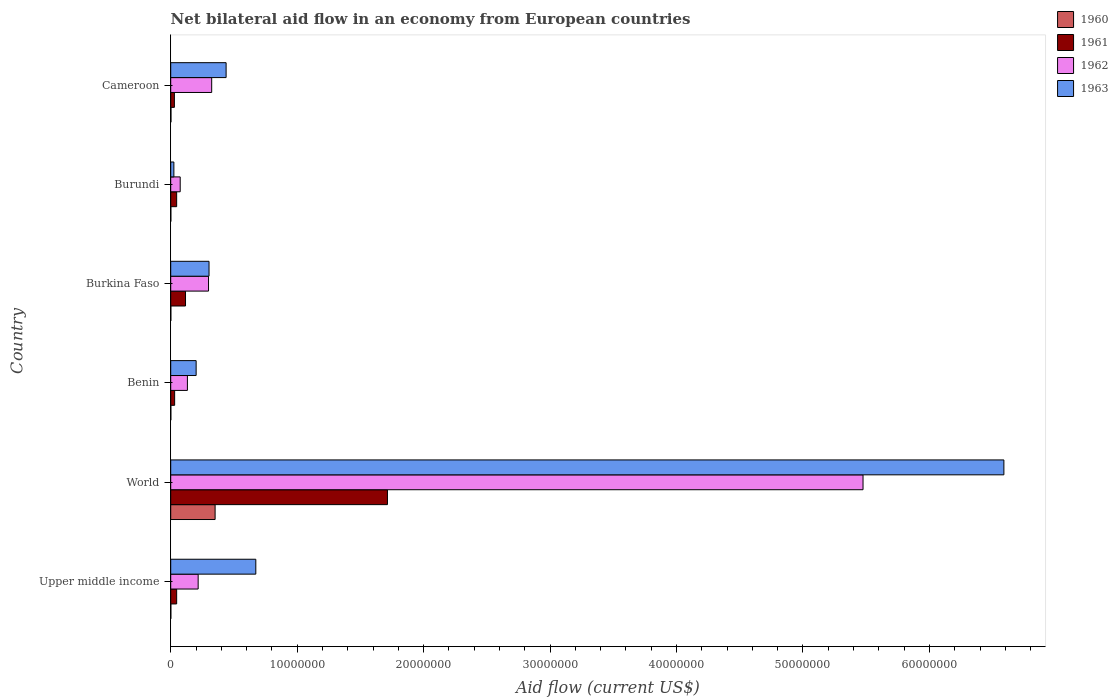How many different coloured bars are there?
Your answer should be very brief. 4. How many groups of bars are there?
Your answer should be very brief. 6. How many bars are there on the 5th tick from the top?
Provide a short and direct response. 4. How many bars are there on the 3rd tick from the bottom?
Give a very brief answer. 4. What is the label of the 2nd group of bars from the top?
Make the answer very short. Burundi. In how many cases, is the number of bars for a given country not equal to the number of legend labels?
Your answer should be compact. 0. Across all countries, what is the maximum net bilateral aid flow in 1960?
Provide a succinct answer. 3.51e+06. Across all countries, what is the minimum net bilateral aid flow in 1960?
Make the answer very short. 10000. In which country was the net bilateral aid flow in 1963 maximum?
Provide a short and direct response. World. In which country was the net bilateral aid flow in 1960 minimum?
Give a very brief answer. Upper middle income. What is the total net bilateral aid flow in 1962 in the graph?
Offer a very short reply. 6.52e+07. What is the difference between the net bilateral aid flow in 1960 in Burundi and that in Cameroon?
Offer a very short reply. -10000. What is the difference between the net bilateral aid flow in 1962 in Burkina Faso and the net bilateral aid flow in 1960 in Benin?
Give a very brief answer. 2.98e+06. What is the average net bilateral aid flow in 1963 per country?
Keep it short and to the point. 1.37e+07. What is the difference between the net bilateral aid flow in 1961 and net bilateral aid flow in 1963 in Cameroon?
Your answer should be compact. -4.09e+06. In how many countries, is the net bilateral aid flow in 1962 greater than 16000000 US$?
Provide a short and direct response. 1. What is the ratio of the net bilateral aid flow in 1961 in Benin to that in Burundi?
Provide a short and direct response. 0.66. Is the difference between the net bilateral aid flow in 1961 in Cameroon and World greater than the difference between the net bilateral aid flow in 1963 in Cameroon and World?
Offer a terse response. Yes. What is the difference between the highest and the second highest net bilateral aid flow in 1963?
Ensure brevity in your answer.  5.92e+07. What is the difference between the highest and the lowest net bilateral aid flow in 1960?
Your answer should be compact. 3.50e+06. Is it the case that in every country, the sum of the net bilateral aid flow in 1962 and net bilateral aid flow in 1963 is greater than the sum of net bilateral aid flow in 1961 and net bilateral aid flow in 1960?
Your response must be concise. No. Is it the case that in every country, the sum of the net bilateral aid flow in 1961 and net bilateral aid flow in 1963 is greater than the net bilateral aid flow in 1962?
Ensure brevity in your answer.  No. How many bars are there?
Offer a very short reply. 24. Are all the bars in the graph horizontal?
Provide a short and direct response. Yes. How many countries are there in the graph?
Your answer should be compact. 6. Does the graph contain grids?
Your answer should be compact. No. Where does the legend appear in the graph?
Make the answer very short. Top right. How many legend labels are there?
Your response must be concise. 4. How are the legend labels stacked?
Keep it short and to the point. Vertical. What is the title of the graph?
Make the answer very short. Net bilateral aid flow in an economy from European countries. Does "1999" appear as one of the legend labels in the graph?
Make the answer very short. No. What is the label or title of the X-axis?
Keep it short and to the point. Aid flow (current US$). What is the label or title of the Y-axis?
Offer a very short reply. Country. What is the Aid flow (current US$) in 1961 in Upper middle income?
Provide a short and direct response. 4.70e+05. What is the Aid flow (current US$) of 1962 in Upper middle income?
Give a very brief answer. 2.17e+06. What is the Aid flow (current US$) in 1963 in Upper middle income?
Your response must be concise. 6.73e+06. What is the Aid flow (current US$) of 1960 in World?
Make the answer very short. 3.51e+06. What is the Aid flow (current US$) of 1961 in World?
Provide a short and direct response. 1.71e+07. What is the Aid flow (current US$) of 1962 in World?
Provide a succinct answer. 5.48e+07. What is the Aid flow (current US$) of 1963 in World?
Give a very brief answer. 6.59e+07. What is the Aid flow (current US$) of 1960 in Benin?
Make the answer very short. 10000. What is the Aid flow (current US$) of 1961 in Benin?
Offer a very short reply. 3.10e+05. What is the Aid flow (current US$) in 1962 in Benin?
Provide a short and direct response. 1.32e+06. What is the Aid flow (current US$) of 1963 in Benin?
Your answer should be very brief. 2.01e+06. What is the Aid flow (current US$) in 1960 in Burkina Faso?
Your answer should be compact. 10000. What is the Aid flow (current US$) in 1961 in Burkina Faso?
Your response must be concise. 1.17e+06. What is the Aid flow (current US$) of 1962 in Burkina Faso?
Your answer should be compact. 2.99e+06. What is the Aid flow (current US$) of 1963 in Burkina Faso?
Offer a very short reply. 3.03e+06. What is the Aid flow (current US$) in 1960 in Burundi?
Provide a succinct answer. 10000. What is the Aid flow (current US$) of 1961 in Burundi?
Offer a very short reply. 4.70e+05. What is the Aid flow (current US$) of 1962 in Burundi?
Give a very brief answer. 7.50e+05. What is the Aid flow (current US$) in 1963 in Burundi?
Keep it short and to the point. 2.50e+05. What is the Aid flow (current US$) in 1962 in Cameroon?
Keep it short and to the point. 3.24e+06. What is the Aid flow (current US$) in 1963 in Cameroon?
Offer a terse response. 4.38e+06. Across all countries, what is the maximum Aid flow (current US$) in 1960?
Your answer should be very brief. 3.51e+06. Across all countries, what is the maximum Aid flow (current US$) of 1961?
Provide a succinct answer. 1.71e+07. Across all countries, what is the maximum Aid flow (current US$) of 1962?
Give a very brief answer. 5.48e+07. Across all countries, what is the maximum Aid flow (current US$) of 1963?
Offer a terse response. 6.59e+07. Across all countries, what is the minimum Aid flow (current US$) in 1960?
Offer a terse response. 10000. Across all countries, what is the minimum Aid flow (current US$) in 1961?
Offer a terse response. 2.90e+05. Across all countries, what is the minimum Aid flow (current US$) in 1962?
Your answer should be very brief. 7.50e+05. What is the total Aid flow (current US$) of 1960 in the graph?
Give a very brief answer. 3.57e+06. What is the total Aid flow (current US$) in 1961 in the graph?
Your response must be concise. 1.98e+07. What is the total Aid flow (current US$) in 1962 in the graph?
Give a very brief answer. 6.52e+07. What is the total Aid flow (current US$) of 1963 in the graph?
Your response must be concise. 8.23e+07. What is the difference between the Aid flow (current US$) of 1960 in Upper middle income and that in World?
Provide a short and direct response. -3.50e+06. What is the difference between the Aid flow (current US$) in 1961 in Upper middle income and that in World?
Your response must be concise. -1.67e+07. What is the difference between the Aid flow (current US$) in 1962 in Upper middle income and that in World?
Offer a very short reply. -5.26e+07. What is the difference between the Aid flow (current US$) of 1963 in Upper middle income and that in World?
Offer a terse response. -5.92e+07. What is the difference between the Aid flow (current US$) of 1960 in Upper middle income and that in Benin?
Your answer should be compact. 0. What is the difference between the Aid flow (current US$) of 1962 in Upper middle income and that in Benin?
Give a very brief answer. 8.50e+05. What is the difference between the Aid flow (current US$) of 1963 in Upper middle income and that in Benin?
Provide a short and direct response. 4.72e+06. What is the difference between the Aid flow (current US$) of 1961 in Upper middle income and that in Burkina Faso?
Provide a succinct answer. -7.00e+05. What is the difference between the Aid flow (current US$) in 1962 in Upper middle income and that in Burkina Faso?
Ensure brevity in your answer.  -8.20e+05. What is the difference between the Aid flow (current US$) in 1963 in Upper middle income and that in Burkina Faso?
Ensure brevity in your answer.  3.70e+06. What is the difference between the Aid flow (current US$) in 1962 in Upper middle income and that in Burundi?
Provide a short and direct response. 1.42e+06. What is the difference between the Aid flow (current US$) of 1963 in Upper middle income and that in Burundi?
Your answer should be very brief. 6.48e+06. What is the difference between the Aid flow (current US$) in 1960 in Upper middle income and that in Cameroon?
Make the answer very short. -10000. What is the difference between the Aid flow (current US$) in 1961 in Upper middle income and that in Cameroon?
Provide a short and direct response. 1.80e+05. What is the difference between the Aid flow (current US$) in 1962 in Upper middle income and that in Cameroon?
Ensure brevity in your answer.  -1.07e+06. What is the difference between the Aid flow (current US$) of 1963 in Upper middle income and that in Cameroon?
Provide a succinct answer. 2.35e+06. What is the difference between the Aid flow (current US$) in 1960 in World and that in Benin?
Provide a succinct answer. 3.50e+06. What is the difference between the Aid flow (current US$) in 1961 in World and that in Benin?
Keep it short and to the point. 1.68e+07. What is the difference between the Aid flow (current US$) in 1962 in World and that in Benin?
Your answer should be very brief. 5.34e+07. What is the difference between the Aid flow (current US$) in 1963 in World and that in Benin?
Offer a terse response. 6.39e+07. What is the difference between the Aid flow (current US$) of 1960 in World and that in Burkina Faso?
Your answer should be compact. 3.50e+06. What is the difference between the Aid flow (current US$) in 1961 in World and that in Burkina Faso?
Keep it short and to the point. 1.60e+07. What is the difference between the Aid flow (current US$) in 1962 in World and that in Burkina Faso?
Ensure brevity in your answer.  5.18e+07. What is the difference between the Aid flow (current US$) in 1963 in World and that in Burkina Faso?
Provide a short and direct response. 6.29e+07. What is the difference between the Aid flow (current US$) in 1960 in World and that in Burundi?
Provide a short and direct response. 3.50e+06. What is the difference between the Aid flow (current US$) in 1961 in World and that in Burundi?
Ensure brevity in your answer.  1.67e+07. What is the difference between the Aid flow (current US$) of 1962 in World and that in Burundi?
Offer a terse response. 5.40e+07. What is the difference between the Aid flow (current US$) in 1963 in World and that in Burundi?
Offer a very short reply. 6.56e+07. What is the difference between the Aid flow (current US$) in 1960 in World and that in Cameroon?
Your response must be concise. 3.49e+06. What is the difference between the Aid flow (current US$) of 1961 in World and that in Cameroon?
Make the answer very short. 1.68e+07. What is the difference between the Aid flow (current US$) in 1962 in World and that in Cameroon?
Your answer should be compact. 5.15e+07. What is the difference between the Aid flow (current US$) of 1963 in World and that in Cameroon?
Your answer should be compact. 6.15e+07. What is the difference between the Aid flow (current US$) of 1960 in Benin and that in Burkina Faso?
Give a very brief answer. 0. What is the difference between the Aid flow (current US$) of 1961 in Benin and that in Burkina Faso?
Your answer should be very brief. -8.60e+05. What is the difference between the Aid flow (current US$) of 1962 in Benin and that in Burkina Faso?
Ensure brevity in your answer.  -1.67e+06. What is the difference between the Aid flow (current US$) of 1963 in Benin and that in Burkina Faso?
Make the answer very short. -1.02e+06. What is the difference between the Aid flow (current US$) of 1961 in Benin and that in Burundi?
Keep it short and to the point. -1.60e+05. What is the difference between the Aid flow (current US$) of 1962 in Benin and that in Burundi?
Provide a succinct answer. 5.70e+05. What is the difference between the Aid flow (current US$) of 1963 in Benin and that in Burundi?
Keep it short and to the point. 1.76e+06. What is the difference between the Aid flow (current US$) of 1960 in Benin and that in Cameroon?
Your answer should be very brief. -10000. What is the difference between the Aid flow (current US$) of 1962 in Benin and that in Cameroon?
Make the answer very short. -1.92e+06. What is the difference between the Aid flow (current US$) in 1963 in Benin and that in Cameroon?
Your answer should be compact. -2.37e+06. What is the difference between the Aid flow (current US$) in 1962 in Burkina Faso and that in Burundi?
Provide a succinct answer. 2.24e+06. What is the difference between the Aid flow (current US$) of 1963 in Burkina Faso and that in Burundi?
Your response must be concise. 2.78e+06. What is the difference between the Aid flow (current US$) of 1960 in Burkina Faso and that in Cameroon?
Give a very brief answer. -10000. What is the difference between the Aid flow (current US$) in 1961 in Burkina Faso and that in Cameroon?
Give a very brief answer. 8.80e+05. What is the difference between the Aid flow (current US$) of 1963 in Burkina Faso and that in Cameroon?
Offer a terse response. -1.35e+06. What is the difference between the Aid flow (current US$) in 1962 in Burundi and that in Cameroon?
Your answer should be very brief. -2.49e+06. What is the difference between the Aid flow (current US$) of 1963 in Burundi and that in Cameroon?
Your answer should be compact. -4.13e+06. What is the difference between the Aid flow (current US$) in 1960 in Upper middle income and the Aid flow (current US$) in 1961 in World?
Offer a very short reply. -1.71e+07. What is the difference between the Aid flow (current US$) in 1960 in Upper middle income and the Aid flow (current US$) in 1962 in World?
Your answer should be compact. -5.47e+07. What is the difference between the Aid flow (current US$) in 1960 in Upper middle income and the Aid flow (current US$) in 1963 in World?
Provide a short and direct response. -6.59e+07. What is the difference between the Aid flow (current US$) in 1961 in Upper middle income and the Aid flow (current US$) in 1962 in World?
Ensure brevity in your answer.  -5.43e+07. What is the difference between the Aid flow (current US$) of 1961 in Upper middle income and the Aid flow (current US$) of 1963 in World?
Provide a succinct answer. -6.54e+07. What is the difference between the Aid flow (current US$) of 1962 in Upper middle income and the Aid flow (current US$) of 1963 in World?
Give a very brief answer. -6.37e+07. What is the difference between the Aid flow (current US$) of 1960 in Upper middle income and the Aid flow (current US$) of 1961 in Benin?
Offer a terse response. -3.00e+05. What is the difference between the Aid flow (current US$) of 1960 in Upper middle income and the Aid flow (current US$) of 1962 in Benin?
Give a very brief answer. -1.31e+06. What is the difference between the Aid flow (current US$) of 1961 in Upper middle income and the Aid flow (current US$) of 1962 in Benin?
Give a very brief answer. -8.50e+05. What is the difference between the Aid flow (current US$) in 1961 in Upper middle income and the Aid flow (current US$) in 1963 in Benin?
Provide a succinct answer. -1.54e+06. What is the difference between the Aid flow (current US$) in 1962 in Upper middle income and the Aid flow (current US$) in 1963 in Benin?
Ensure brevity in your answer.  1.60e+05. What is the difference between the Aid flow (current US$) in 1960 in Upper middle income and the Aid flow (current US$) in 1961 in Burkina Faso?
Your response must be concise. -1.16e+06. What is the difference between the Aid flow (current US$) in 1960 in Upper middle income and the Aid flow (current US$) in 1962 in Burkina Faso?
Offer a terse response. -2.98e+06. What is the difference between the Aid flow (current US$) of 1960 in Upper middle income and the Aid flow (current US$) of 1963 in Burkina Faso?
Make the answer very short. -3.02e+06. What is the difference between the Aid flow (current US$) in 1961 in Upper middle income and the Aid flow (current US$) in 1962 in Burkina Faso?
Give a very brief answer. -2.52e+06. What is the difference between the Aid flow (current US$) in 1961 in Upper middle income and the Aid flow (current US$) in 1963 in Burkina Faso?
Provide a succinct answer. -2.56e+06. What is the difference between the Aid flow (current US$) in 1962 in Upper middle income and the Aid flow (current US$) in 1963 in Burkina Faso?
Provide a succinct answer. -8.60e+05. What is the difference between the Aid flow (current US$) in 1960 in Upper middle income and the Aid flow (current US$) in 1961 in Burundi?
Keep it short and to the point. -4.60e+05. What is the difference between the Aid flow (current US$) in 1960 in Upper middle income and the Aid flow (current US$) in 1962 in Burundi?
Provide a succinct answer. -7.40e+05. What is the difference between the Aid flow (current US$) of 1960 in Upper middle income and the Aid flow (current US$) of 1963 in Burundi?
Make the answer very short. -2.40e+05. What is the difference between the Aid flow (current US$) in 1961 in Upper middle income and the Aid flow (current US$) in 1962 in Burundi?
Make the answer very short. -2.80e+05. What is the difference between the Aid flow (current US$) in 1962 in Upper middle income and the Aid flow (current US$) in 1963 in Burundi?
Give a very brief answer. 1.92e+06. What is the difference between the Aid flow (current US$) of 1960 in Upper middle income and the Aid flow (current US$) of 1961 in Cameroon?
Offer a terse response. -2.80e+05. What is the difference between the Aid flow (current US$) in 1960 in Upper middle income and the Aid flow (current US$) in 1962 in Cameroon?
Your answer should be very brief. -3.23e+06. What is the difference between the Aid flow (current US$) in 1960 in Upper middle income and the Aid flow (current US$) in 1963 in Cameroon?
Provide a short and direct response. -4.37e+06. What is the difference between the Aid flow (current US$) in 1961 in Upper middle income and the Aid flow (current US$) in 1962 in Cameroon?
Provide a succinct answer. -2.77e+06. What is the difference between the Aid flow (current US$) of 1961 in Upper middle income and the Aid flow (current US$) of 1963 in Cameroon?
Give a very brief answer. -3.91e+06. What is the difference between the Aid flow (current US$) of 1962 in Upper middle income and the Aid flow (current US$) of 1963 in Cameroon?
Give a very brief answer. -2.21e+06. What is the difference between the Aid flow (current US$) of 1960 in World and the Aid flow (current US$) of 1961 in Benin?
Your answer should be very brief. 3.20e+06. What is the difference between the Aid flow (current US$) in 1960 in World and the Aid flow (current US$) in 1962 in Benin?
Offer a terse response. 2.19e+06. What is the difference between the Aid flow (current US$) in 1960 in World and the Aid flow (current US$) in 1963 in Benin?
Provide a short and direct response. 1.50e+06. What is the difference between the Aid flow (current US$) in 1961 in World and the Aid flow (current US$) in 1962 in Benin?
Offer a very short reply. 1.58e+07. What is the difference between the Aid flow (current US$) in 1961 in World and the Aid flow (current US$) in 1963 in Benin?
Provide a succinct answer. 1.51e+07. What is the difference between the Aid flow (current US$) of 1962 in World and the Aid flow (current US$) of 1963 in Benin?
Make the answer very short. 5.27e+07. What is the difference between the Aid flow (current US$) of 1960 in World and the Aid flow (current US$) of 1961 in Burkina Faso?
Your answer should be very brief. 2.34e+06. What is the difference between the Aid flow (current US$) in 1960 in World and the Aid flow (current US$) in 1962 in Burkina Faso?
Make the answer very short. 5.20e+05. What is the difference between the Aid flow (current US$) in 1960 in World and the Aid flow (current US$) in 1963 in Burkina Faso?
Offer a very short reply. 4.80e+05. What is the difference between the Aid flow (current US$) of 1961 in World and the Aid flow (current US$) of 1962 in Burkina Faso?
Your answer should be very brief. 1.42e+07. What is the difference between the Aid flow (current US$) of 1961 in World and the Aid flow (current US$) of 1963 in Burkina Faso?
Offer a terse response. 1.41e+07. What is the difference between the Aid flow (current US$) in 1962 in World and the Aid flow (current US$) in 1963 in Burkina Faso?
Make the answer very short. 5.17e+07. What is the difference between the Aid flow (current US$) of 1960 in World and the Aid flow (current US$) of 1961 in Burundi?
Provide a short and direct response. 3.04e+06. What is the difference between the Aid flow (current US$) in 1960 in World and the Aid flow (current US$) in 1962 in Burundi?
Provide a succinct answer. 2.76e+06. What is the difference between the Aid flow (current US$) of 1960 in World and the Aid flow (current US$) of 1963 in Burundi?
Give a very brief answer. 3.26e+06. What is the difference between the Aid flow (current US$) in 1961 in World and the Aid flow (current US$) in 1962 in Burundi?
Ensure brevity in your answer.  1.64e+07. What is the difference between the Aid flow (current US$) in 1961 in World and the Aid flow (current US$) in 1963 in Burundi?
Give a very brief answer. 1.69e+07. What is the difference between the Aid flow (current US$) of 1962 in World and the Aid flow (current US$) of 1963 in Burundi?
Provide a short and direct response. 5.45e+07. What is the difference between the Aid flow (current US$) in 1960 in World and the Aid flow (current US$) in 1961 in Cameroon?
Offer a terse response. 3.22e+06. What is the difference between the Aid flow (current US$) of 1960 in World and the Aid flow (current US$) of 1963 in Cameroon?
Make the answer very short. -8.70e+05. What is the difference between the Aid flow (current US$) in 1961 in World and the Aid flow (current US$) in 1962 in Cameroon?
Offer a terse response. 1.39e+07. What is the difference between the Aid flow (current US$) of 1961 in World and the Aid flow (current US$) of 1963 in Cameroon?
Offer a very short reply. 1.28e+07. What is the difference between the Aid flow (current US$) in 1962 in World and the Aid flow (current US$) in 1963 in Cameroon?
Ensure brevity in your answer.  5.04e+07. What is the difference between the Aid flow (current US$) of 1960 in Benin and the Aid flow (current US$) of 1961 in Burkina Faso?
Ensure brevity in your answer.  -1.16e+06. What is the difference between the Aid flow (current US$) in 1960 in Benin and the Aid flow (current US$) in 1962 in Burkina Faso?
Your answer should be compact. -2.98e+06. What is the difference between the Aid flow (current US$) in 1960 in Benin and the Aid flow (current US$) in 1963 in Burkina Faso?
Make the answer very short. -3.02e+06. What is the difference between the Aid flow (current US$) of 1961 in Benin and the Aid flow (current US$) of 1962 in Burkina Faso?
Your answer should be very brief. -2.68e+06. What is the difference between the Aid flow (current US$) in 1961 in Benin and the Aid flow (current US$) in 1963 in Burkina Faso?
Give a very brief answer. -2.72e+06. What is the difference between the Aid flow (current US$) of 1962 in Benin and the Aid flow (current US$) of 1963 in Burkina Faso?
Make the answer very short. -1.71e+06. What is the difference between the Aid flow (current US$) in 1960 in Benin and the Aid flow (current US$) in 1961 in Burundi?
Ensure brevity in your answer.  -4.60e+05. What is the difference between the Aid flow (current US$) of 1960 in Benin and the Aid flow (current US$) of 1962 in Burundi?
Your answer should be compact. -7.40e+05. What is the difference between the Aid flow (current US$) in 1961 in Benin and the Aid flow (current US$) in 1962 in Burundi?
Your answer should be very brief. -4.40e+05. What is the difference between the Aid flow (current US$) of 1961 in Benin and the Aid flow (current US$) of 1963 in Burundi?
Ensure brevity in your answer.  6.00e+04. What is the difference between the Aid flow (current US$) of 1962 in Benin and the Aid flow (current US$) of 1963 in Burundi?
Keep it short and to the point. 1.07e+06. What is the difference between the Aid flow (current US$) in 1960 in Benin and the Aid flow (current US$) in 1961 in Cameroon?
Give a very brief answer. -2.80e+05. What is the difference between the Aid flow (current US$) in 1960 in Benin and the Aid flow (current US$) in 1962 in Cameroon?
Make the answer very short. -3.23e+06. What is the difference between the Aid flow (current US$) in 1960 in Benin and the Aid flow (current US$) in 1963 in Cameroon?
Provide a succinct answer. -4.37e+06. What is the difference between the Aid flow (current US$) of 1961 in Benin and the Aid flow (current US$) of 1962 in Cameroon?
Provide a short and direct response. -2.93e+06. What is the difference between the Aid flow (current US$) in 1961 in Benin and the Aid flow (current US$) in 1963 in Cameroon?
Provide a succinct answer. -4.07e+06. What is the difference between the Aid flow (current US$) in 1962 in Benin and the Aid flow (current US$) in 1963 in Cameroon?
Your answer should be very brief. -3.06e+06. What is the difference between the Aid flow (current US$) of 1960 in Burkina Faso and the Aid flow (current US$) of 1961 in Burundi?
Your answer should be compact. -4.60e+05. What is the difference between the Aid flow (current US$) of 1960 in Burkina Faso and the Aid flow (current US$) of 1962 in Burundi?
Provide a short and direct response. -7.40e+05. What is the difference between the Aid flow (current US$) in 1960 in Burkina Faso and the Aid flow (current US$) in 1963 in Burundi?
Your answer should be very brief. -2.40e+05. What is the difference between the Aid flow (current US$) of 1961 in Burkina Faso and the Aid flow (current US$) of 1963 in Burundi?
Provide a succinct answer. 9.20e+05. What is the difference between the Aid flow (current US$) in 1962 in Burkina Faso and the Aid flow (current US$) in 1963 in Burundi?
Your response must be concise. 2.74e+06. What is the difference between the Aid flow (current US$) of 1960 in Burkina Faso and the Aid flow (current US$) of 1961 in Cameroon?
Offer a very short reply. -2.80e+05. What is the difference between the Aid flow (current US$) in 1960 in Burkina Faso and the Aid flow (current US$) in 1962 in Cameroon?
Offer a very short reply. -3.23e+06. What is the difference between the Aid flow (current US$) of 1960 in Burkina Faso and the Aid flow (current US$) of 1963 in Cameroon?
Provide a succinct answer. -4.37e+06. What is the difference between the Aid flow (current US$) of 1961 in Burkina Faso and the Aid flow (current US$) of 1962 in Cameroon?
Give a very brief answer. -2.07e+06. What is the difference between the Aid flow (current US$) in 1961 in Burkina Faso and the Aid flow (current US$) in 1963 in Cameroon?
Your response must be concise. -3.21e+06. What is the difference between the Aid flow (current US$) of 1962 in Burkina Faso and the Aid flow (current US$) of 1963 in Cameroon?
Your answer should be compact. -1.39e+06. What is the difference between the Aid flow (current US$) in 1960 in Burundi and the Aid flow (current US$) in 1961 in Cameroon?
Make the answer very short. -2.80e+05. What is the difference between the Aid flow (current US$) of 1960 in Burundi and the Aid flow (current US$) of 1962 in Cameroon?
Make the answer very short. -3.23e+06. What is the difference between the Aid flow (current US$) in 1960 in Burundi and the Aid flow (current US$) in 1963 in Cameroon?
Keep it short and to the point. -4.37e+06. What is the difference between the Aid flow (current US$) of 1961 in Burundi and the Aid flow (current US$) of 1962 in Cameroon?
Make the answer very short. -2.77e+06. What is the difference between the Aid flow (current US$) in 1961 in Burundi and the Aid flow (current US$) in 1963 in Cameroon?
Ensure brevity in your answer.  -3.91e+06. What is the difference between the Aid flow (current US$) in 1962 in Burundi and the Aid flow (current US$) in 1963 in Cameroon?
Make the answer very short. -3.63e+06. What is the average Aid flow (current US$) of 1960 per country?
Offer a terse response. 5.95e+05. What is the average Aid flow (current US$) of 1961 per country?
Offer a terse response. 3.31e+06. What is the average Aid flow (current US$) in 1962 per country?
Provide a short and direct response. 1.09e+07. What is the average Aid flow (current US$) of 1963 per country?
Your response must be concise. 1.37e+07. What is the difference between the Aid flow (current US$) in 1960 and Aid flow (current US$) in 1961 in Upper middle income?
Ensure brevity in your answer.  -4.60e+05. What is the difference between the Aid flow (current US$) of 1960 and Aid flow (current US$) of 1962 in Upper middle income?
Make the answer very short. -2.16e+06. What is the difference between the Aid flow (current US$) in 1960 and Aid flow (current US$) in 1963 in Upper middle income?
Ensure brevity in your answer.  -6.72e+06. What is the difference between the Aid flow (current US$) of 1961 and Aid flow (current US$) of 1962 in Upper middle income?
Provide a succinct answer. -1.70e+06. What is the difference between the Aid flow (current US$) of 1961 and Aid flow (current US$) of 1963 in Upper middle income?
Your answer should be very brief. -6.26e+06. What is the difference between the Aid flow (current US$) of 1962 and Aid flow (current US$) of 1963 in Upper middle income?
Your answer should be compact. -4.56e+06. What is the difference between the Aid flow (current US$) in 1960 and Aid flow (current US$) in 1961 in World?
Give a very brief answer. -1.36e+07. What is the difference between the Aid flow (current US$) in 1960 and Aid flow (current US$) in 1962 in World?
Give a very brief answer. -5.12e+07. What is the difference between the Aid flow (current US$) in 1960 and Aid flow (current US$) in 1963 in World?
Offer a terse response. -6.24e+07. What is the difference between the Aid flow (current US$) in 1961 and Aid flow (current US$) in 1962 in World?
Your response must be concise. -3.76e+07. What is the difference between the Aid flow (current US$) in 1961 and Aid flow (current US$) in 1963 in World?
Provide a succinct answer. -4.88e+07. What is the difference between the Aid flow (current US$) of 1962 and Aid flow (current US$) of 1963 in World?
Keep it short and to the point. -1.11e+07. What is the difference between the Aid flow (current US$) in 1960 and Aid flow (current US$) in 1961 in Benin?
Provide a succinct answer. -3.00e+05. What is the difference between the Aid flow (current US$) of 1960 and Aid flow (current US$) of 1962 in Benin?
Your response must be concise. -1.31e+06. What is the difference between the Aid flow (current US$) of 1961 and Aid flow (current US$) of 1962 in Benin?
Your response must be concise. -1.01e+06. What is the difference between the Aid flow (current US$) in 1961 and Aid flow (current US$) in 1963 in Benin?
Provide a succinct answer. -1.70e+06. What is the difference between the Aid flow (current US$) of 1962 and Aid flow (current US$) of 1963 in Benin?
Provide a succinct answer. -6.90e+05. What is the difference between the Aid flow (current US$) in 1960 and Aid flow (current US$) in 1961 in Burkina Faso?
Provide a short and direct response. -1.16e+06. What is the difference between the Aid flow (current US$) in 1960 and Aid flow (current US$) in 1962 in Burkina Faso?
Provide a succinct answer. -2.98e+06. What is the difference between the Aid flow (current US$) of 1960 and Aid flow (current US$) of 1963 in Burkina Faso?
Provide a short and direct response. -3.02e+06. What is the difference between the Aid flow (current US$) in 1961 and Aid flow (current US$) in 1962 in Burkina Faso?
Provide a succinct answer. -1.82e+06. What is the difference between the Aid flow (current US$) in 1961 and Aid flow (current US$) in 1963 in Burkina Faso?
Make the answer very short. -1.86e+06. What is the difference between the Aid flow (current US$) in 1962 and Aid flow (current US$) in 1963 in Burkina Faso?
Provide a short and direct response. -4.00e+04. What is the difference between the Aid flow (current US$) of 1960 and Aid flow (current US$) of 1961 in Burundi?
Give a very brief answer. -4.60e+05. What is the difference between the Aid flow (current US$) of 1960 and Aid flow (current US$) of 1962 in Burundi?
Ensure brevity in your answer.  -7.40e+05. What is the difference between the Aid flow (current US$) in 1961 and Aid flow (current US$) in 1962 in Burundi?
Offer a terse response. -2.80e+05. What is the difference between the Aid flow (current US$) of 1961 and Aid flow (current US$) of 1963 in Burundi?
Ensure brevity in your answer.  2.20e+05. What is the difference between the Aid flow (current US$) of 1960 and Aid flow (current US$) of 1961 in Cameroon?
Offer a terse response. -2.70e+05. What is the difference between the Aid flow (current US$) of 1960 and Aid flow (current US$) of 1962 in Cameroon?
Keep it short and to the point. -3.22e+06. What is the difference between the Aid flow (current US$) of 1960 and Aid flow (current US$) of 1963 in Cameroon?
Your answer should be compact. -4.36e+06. What is the difference between the Aid flow (current US$) in 1961 and Aid flow (current US$) in 1962 in Cameroon?
Ensure brevity in your answer.  -2.95e+06. What is the difference between the Aid flow (current US$) in 1961 and Aid flow (current US$) in 1963 in Cameroon?
Your response must be concise. -4.09e+06. What is the difference between the Aid flow (current US$) in 1962 and Aid flow (current US$) in 1963 in Cameroon?
Your answer should be compact. -1.14e+06. What is the ratio of the Aid flow (current US$) in 1960 in Upper middle income to that in World?
Keep it short and to the point. 0. What is the ratio of the Aid flow (current US$) of 1961 in Upper middle income to that in World?
Your answer should be very brief. 0.03. What is the ratio of the Aid flow (current US$) of 1962 in Upper middle income to that in World?
Your answer should be compact. 0.04. What is the ratio of the Aid flow (current US$) in 1963 in Upper middle income to that in World?
Offer a terse response. 0.1. What is the ratio of the Aid flow (current US$) in 1960 in Upper middle income to that in Benin?
Keep it short and to the point. 1. What is the ratio of the Aid flow (current US$) of 1961 in Upper middle income to that in Benin?
Keep it short and to the point. 1.52. What is the ratio of the Aid flow (current US$) of 1962 in Upper middle income to that in Benin?
Provide a succinct answer. 1.64. What is the ratio of the Aid flow (current US$) of 1963 in Upper middle income to that in Benin?
Keep it short and to the point. 3.35. What is the ratio of the Aid flow (current US$) of 1960 in Upper middle income to that in Burkina Faso?
Provide a succinct answer. 1. What is the ratio of the Aid flow (current US$) of 1961 in Upper middle income to that in Burkina Faso?
Give a very brief answer. 0.4. What is the ratio of the Aid flow (current US$) in 1962 in Upper middle income to that in Burkina Faso?
Offer a terse response. 0.73. What is the ratio of the Aid flow (current US$) in 1963 in Upper middle income to that in Burkina Faso?
Ensure brevity in your answer.  2.22. What is the ratio of the Aid flow (current US$) of 1962 in Upper middle income to that in Burundi?
Your response must be concise. 2.89. What is the ratio of the Aid flow (current US$) of 1963 in Upper middle income to that in Burundi?
Your answer should be very brief. 26.92. What is the ratio of the Aid flow (current US$) of 1960 in Upper middle income to that in Cameroon?
Your answer should be compact. 0.5. What is the ratio of the Aid flow (current US$) of 1961 in Upper middle income to that in Cameroon?
Make the answer very short. 1.62. What is the ratio of the Aid flow (current US$) of 1962 in Upper middle income to that in Cameroon?
Your answer should be very brief. 0.67. What is the ratio of the Aid flow (current US$) of 1963 in Upper middle income to that in Cameroon?
Give a very brief answer. 1.54. What is the ratio of the Aid flow (current US$) in 1960 in World to that in Benin?
Keep it short and to the point. 351. What is the ratio of the Aid flow (current US$) of 1961 in World to that in Benin?
Offer a terse response. 55.29. What is the ratio of the Aid flow (current US$) in 1962 in World to that in Benin?
Offer a very short reply. 41.48. What is the ratio of the Aid flow (current US$) in 1963 in World to that in Benin?
Offer a very short reply. 32.78. What is the ratio of the Aid flow (current US$) in 1960 in World to that in Burkina Faso?
Offer a very short reply. 351. What is the ratio of the Aid flow (current US$) of 1961 in World to that in Burkina Faso?
Your answer should be very brief. 14.65. What is the ratio of the Aid flow (current US$) of 1962 in World to that in Burkina Faso?
Provide a succinct answer. 18.31. What is the ratio of the Aid flow (current US$) in 1963 in World to that in Burkina Faso?
Offer a very short reply. 21.75. What is the ratio of the Aid flow (current US$) in 1960 in World to that in Burundi?
Provide a short and direct response. 351. What is the ratio of the Aid flow (current US$) of 1961 in World to that in Burundi?
Your response must be concise. 36.47. What is the ratio of the Aid flow (current US$) of 1963 in World to that in Burundi?
Offer a terse response. 263.56. What is the ratio of the Aid flow (current US$) in 1960 in World to that in Cameroon?
Your response must be concise. 175.5. What is the ratio of the Aid flow (current US$) in 1961 in World to that in Cameroon?
Your answer should be very brief. 59.1. What is the ratio of the Aid flow (current US$) of 1962 in World to that in Cameroon?
Your response must be concise. 16.9. What is the ratio of the Aid flow (current US$) of 1963 in World to that in Cameroon?
Provide a succinct answer. 15.04. What is the ratio of the Aid flow (current US$) in 1961 in Benin to that in Burkina Faso?
Offer a terse response. 0.27. What is the ratio of the Aid flow (current US$) of 1962 in Benin to that in Burkina Faso?
Give a very brief answer. 0.44. What is the ratio of the Aid flow (current US$) in 1963 in Benin to that in Burkina Faso?
Make the answer very short. 0.66. What is the ratio of the Aid flow (current US$) of 1961 in Benin to that in Burundi?
Provide a short and direct response. 0.66. What is the ratio of the Aid flow (current US$) in 1962 in Benin to that in Burundi?
Offer a terse response. 1.76. What is the ratio of the Aid flow (current US$) of 1963 in Benin to that in Burundi?
Your answer should be very brief. 8.04. What is the ratio of the Aid flow (current US$) of 1960 in Benin to that in Cameroon?
Offer a terse response. 0.5. What is the ratio of the Aid flow (current US$) of 1961 in Benin to that in Cameroon?
Provide a short and direct response. 1.07. What is the ratio of the Aid flow (current US$) in 1962 in Benin to that in Cameroon?
Your answer should be compact. 0.41. What is the ratio of the Aid flow (current US$) of 1963 in Benin to that in Cameroon?
Offer a terse response. 0.46. What is the ratio of the Aid flow (current US$) in 1961 in Burkina Faso to that in Burundi?
Give a very brief answer. 2.49. What is the ratio of the Aid flow (current US$) in 1962 in Burkina Faso to that in Burundi?
Provide a short and direct response. 3.99. What is the ratio of the Aid flow (current US$) of 1963 in Burkina Faso to that in Burundi?
Provide a succinct answer. 12.12. What is the ratio of the Aid flow (current US$) in 1961 in Burkina Faso to that in Cameroon?
Offer a very short reply. 4.03. What is the ratio of the Aid flow (current US$) in 1962 in Burkina Faso to that in Cameroon?
Your answer should be very brief. 0.92. What is the ratio of the Aid flow (current US$) of 1963 in Burkina Faso to that in Cameroon?
Make the answer very short. 0.69. What is the ratio of the Aid flow (current US$) of 1960 in Burundi to that in Cameroon?
Ensure brevity in your answer.  0.5. What is the ratio of the Aid flow (current US$) in 1961 in Burundi to that in Cameroon?
Offer a terse response. 1.62. What is the ratio of the Aid flow (current US$) of 1962 in Burundi to that in Cameroon?
Ensure brevity in your answer.  0.23. What is the ratio of the Aid flow (current US$) in 1963 in Burundi to that in Cameroon?
Offer a terse response. 0.06. What is the difference between the highest and the second highest Aid flow (current US$) in 1960?
Your answer should be compact. 3.49e+06. What is the difference between the highest and the second highest Aid flow (current US$) of 1961?
Your response must be concise. 1.60e+07. What is the difference between the highest and the second highest Aid flow (current US$) of 1962?
Your answer should be very brief. 5.15e+07. What is the difference between the highest and the second highest Aid flow (current US$) in 1963?
Ensure brevity in your answer.  5.92e+07. What is the difference between the highest and the lowest Aid flow (current US$) in 1960?
Give a very brief answer. 3.50e+06. What is the difference between the highest and the lowest Aid flow (current US$) in 1961?
Provide a short and direct response. 1.68e+07. What is the difference between the highest and the lowest Aid flow (current US$) in 1962?
Offer a terse response. 5.40e+07. What is the difference between the highest and the lowest Aid flow (current US$) of 1963?
Keep it short and to the point. 6.56e+07. 